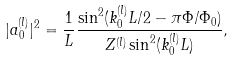Convert formula to latex. <formula><loc_0><loc_0><loc_500><loc_500>| a _ { 0 } ^ { ( l ) } | ^ { 2 } = \frac { 1 } { L } \frac { \sin ^ { 2 } ( k _ { 0 } ^ { ( l ) } L / 2 - \pi \Phi / \Phi _ { 0 } ) } { Z ^ { ( l ) } \sin ^ { 2 } ( k _ { 0 } ^ { ( l ) } L ) } ,</formula> 